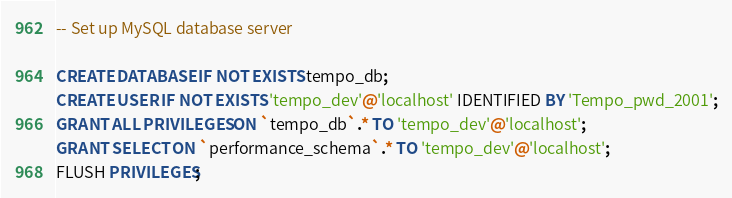<code> <loc_0><loc_0><loc_500><loc_500><_SQL_>-- Set up MySQL database server

CREATE DATABASE IF NOT EXISTS tempo_db;
CREATE USER IF NOT EXISTS 'tempo_dev'@'localhost' IDENTIFIED BY 'Tempo_pwd_2001';
GRANT ALL PRIVILEGES ON `tempo_db`.* TO 'tempo_dev'@'localhost';
GRANT SELECT ON `performance_schema`.* TO 'tempo_dev'@'localhost';
FLUSH PRIVILEGES;
</code> 